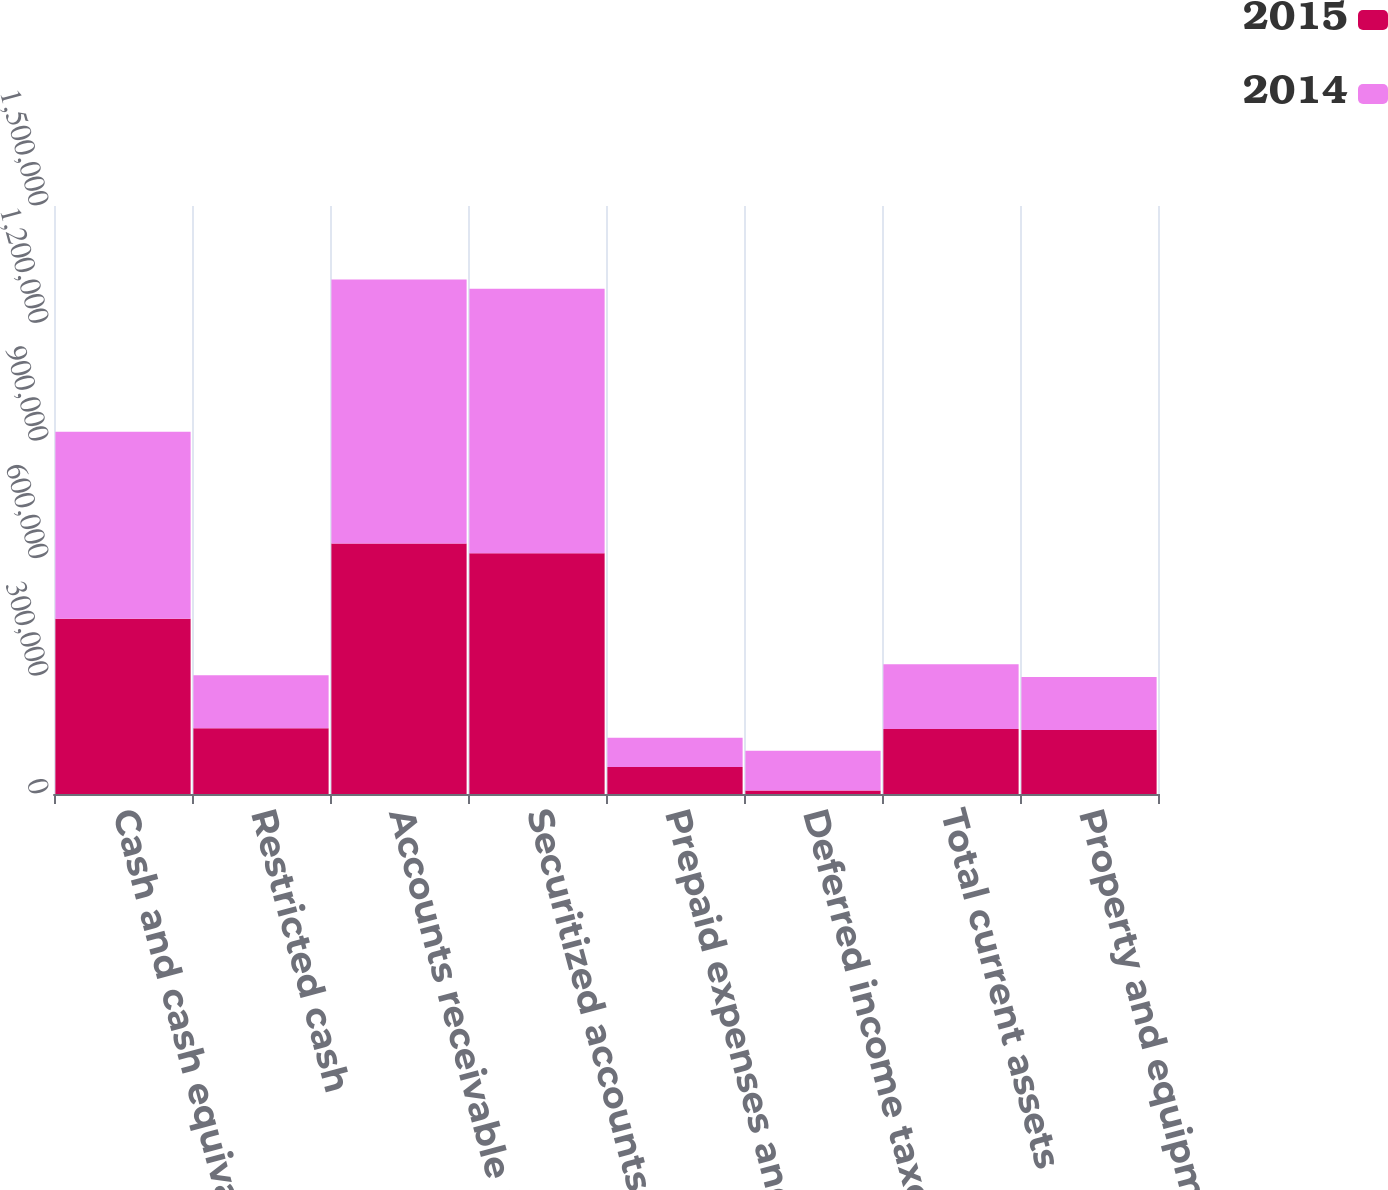Convert chart. <chart><loc_0><loc_0><loc_500><loc_500><stacked_bar_chart><ecel><fcel>Cash and cash equivalents<fcel>Restricted cash<fcel>Accounts receivable (less<fcel>Securitized accounts<fcel>Prepaid expenses and other<fcel>Deferred income taxes<fcel>Total current assets<fcel>Property and equipment<nl><fcel>2015<fcel>447152<fcel>167492<fcel>638954<fcel>614000<fcel>68661<fcel>8913<fcel>165530<fcel>163569<nl><fcel>2014<fcel>477069<fcel>135144<fcel>673797<fcel>675000<fcel>74889<fcel>101451<fcel>165530<fcel>135062<nl></chart> 